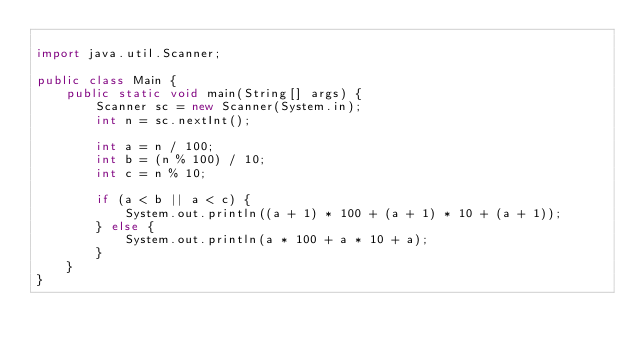Convert code to text. <code><loc_0><loc_0><loc_500><loc_500><_Java_>
import java.util.Scanner;

public class Main {
    public static void main(String[] args) {
        Scanner sc = new Scanner(System.in);
        int n = sc.nextInt();

        int a = n / 100;
        int b = (n % 100) / 10;
        int c = n % 10;

        if (a < b || a < c) {
            System.out.println((a + 1) * 100 + (a + 1) * 10 + (a + 1));
        } else {
            System.out.println(a * 100 + a * 10 + a);
        }
    }
}






</code> 